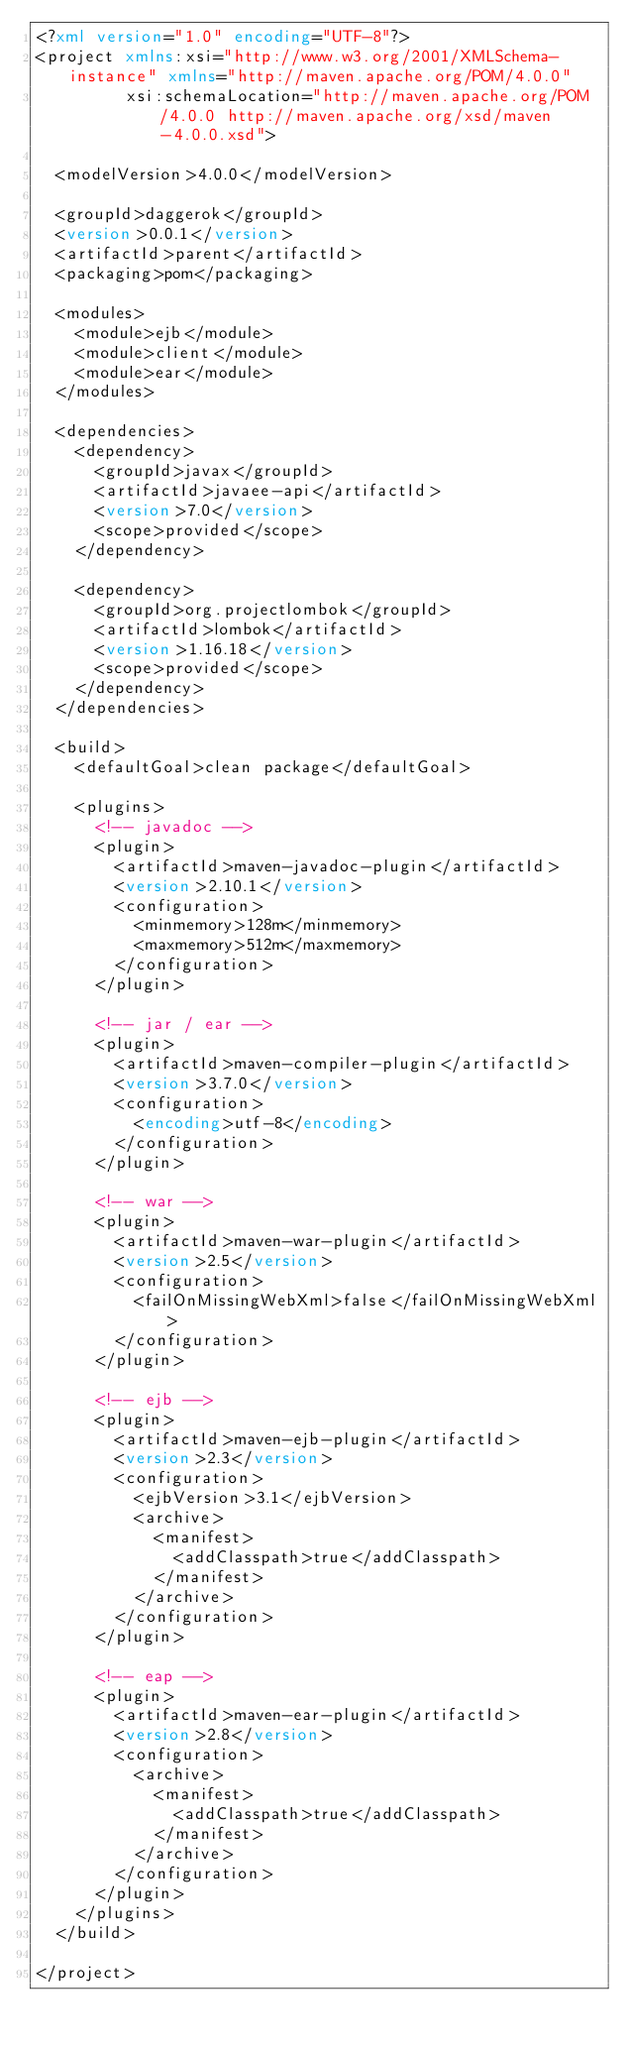<code> <loc_0><loc_0><loc_500><loc_500><_XML_><?xml version="1.0" encoding="UTF-8"?>
<project xmlns:xsi="http://www.w3.org/2001/XMLSchema-instance" xmlns="http://maven.apache.org/POM/4.0.0"
         xsi:schemaLocation="http://maven.apache.org/POM/4.0.0 http://maven.apache.org/xsd/maven-4.0.0.xsd">

  <modelVersion>4.0.0</modelVersion>

  <groupId>daggerok</groupId>
  <version>0.0.1</version>
  <artifactId>parent</artifactId>
  <packaging>pom</packaging>

  <modules>
    <module>ejb</module>
    <module>client</module>
    <module>ear</module>
  </modules>

  <dependencies>
    <dependency>
      <groupId>javax</groupId>
      <artifactId>javaee-api</artifactId>
      <version>7.0</version>
      <scope>provided</scope>
    </dependency>

    <dependency>
      <groupId>org.projectlombok</groupId>
      <artifactId>lombok</artifactId>
      <version>1.16.18</version>
      <scope>provided</scope>
    </dependency>
  </dependencies>

  <build>
    <defaultGoal>clean package</defaultGoal>

    <plugins>
      <!-- javadoc -->
      <plugin>
        <artifactId>maven-javadoc-plugin</artifactId>
        <version>2.10.1</version>
        <configuration>
          <minmemory>128m</minmemory>
          <maxmemory>512m</maxmemory>
        </configuration>
      </plugin>

      <!-- jar / ear -->
      <plugin>
        <artifactId>maven-compiler-plugin</artifactId>
        <version>3.7.0</version>
        <configuration>
          <encoding>utf-8</encoding>
        </configuration>
      </plugin>

      <!-- war -->
      <plugin>
        <artifactId>maven-war-plugin</artifactId>
        <version>2.5</version>
        <configuration>
          <failOnMissingWebXml>false</failOnMissingWebXml>
        </configuration>
      </plugin>

      <!-- ejb -->
      <plugin>
        <artifactId>maven-ejb-plugin</artifactId>
        <version>2.3</version>
        <configuration>
          <ejbVersion>3.1</ejbVersion>
          <archive>
            <manifest>
              <addClasspath>true</addClasspath>
            </manifest>
          </archive>
        </configuration>
      </plugin>

      <!-- eap -->
      <plugin>
        <artifactId>maven-ear-plugin</artifactId>
        <version>2.8</version>
        <configuration>
          <archive>
            <manifest>
              <addClasspath>true</addClasspath>
            </manifest>
          </archive>
        </configuration>
      </plugin>
    </plugins>
  </build>

</project>
</code> 